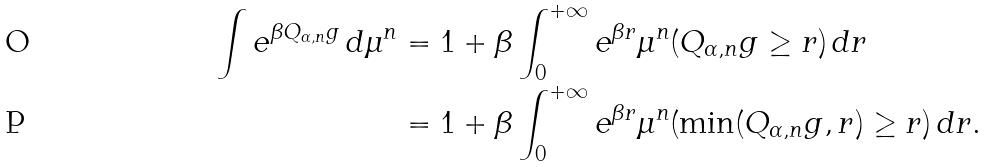Convert formula to latex. <formula><loc_0><loc_0><loc_500><loc_500>\int e ^ { \beta Q _ { \alpha , n } g } \, d \mu ^ { n } & = 1 + \beta \int _ { 0 } ^ { + \infty } e ^ { \beta r } \mu ^ { n } ( Q _ { \alpha , n } g \geq r ) \, d r \\ & = 1 + \beta \int _ { 0 } ^ { + \infty } e ^ { \beta r } \mu ^ { n } ( \min ( Q _ { \alpha , n } g , r ) \geq r ) \, d r .</formula> 